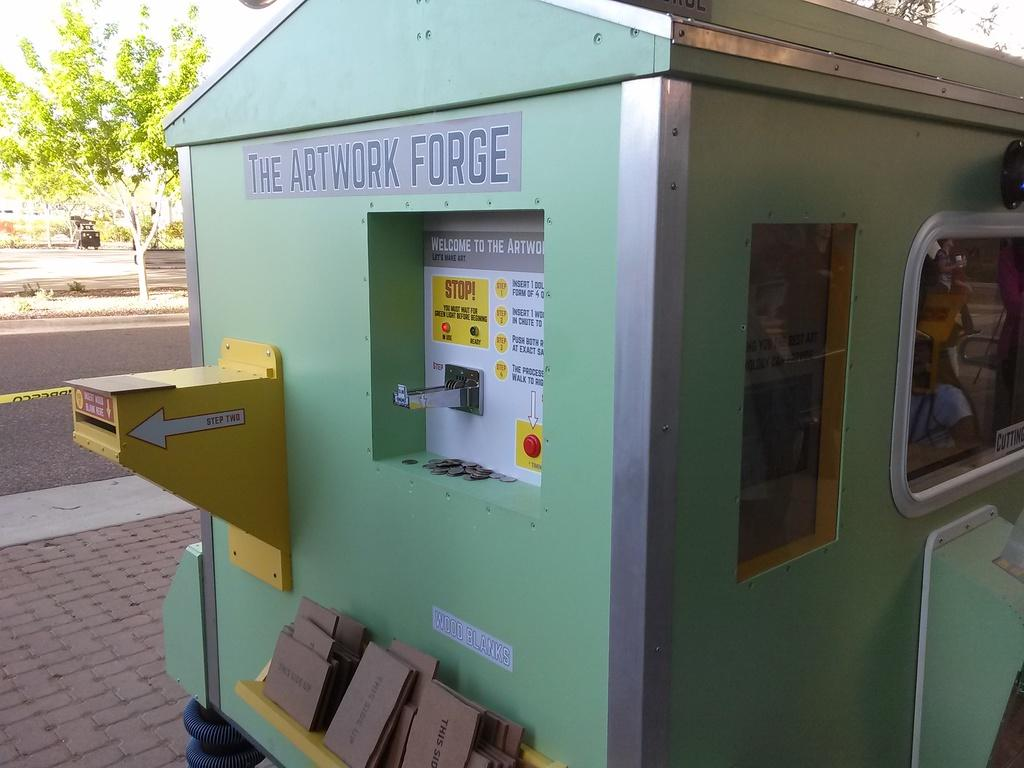Provide a one-sentence caption for the provided image. The Artwork Forge that is located outside in daytime. 